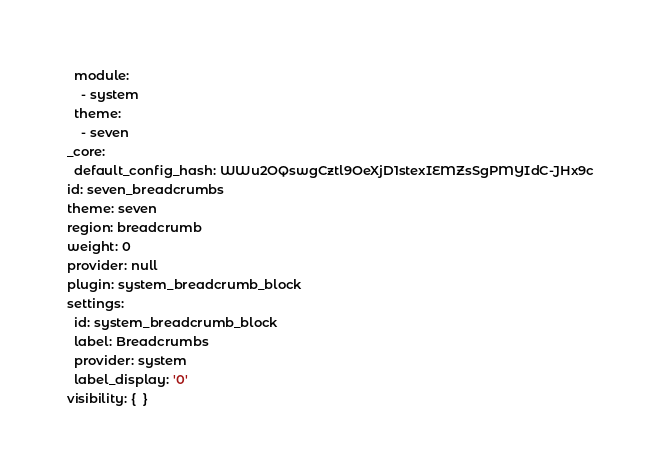Convert code to text. <code><loc_0><loc_0><loc_500><loc_500><_YAML_>  module:
    - system
  theme:
    - seven
_core:
  default_config_hash: WWu2OQswgCztl9OeXjD1stexIEMZsSgPMYIdC-JHx9c
id: seven_breadcrumbs
theme: seven
region: breadcrumb
weight: 0
provider: null
plugin: system_breadcrumb_block
settings:
  id: system_breadcrumb_block
  label: Breadcrumbs
  provider: system
  label_display: '0'
visibility: {  }
</code> 